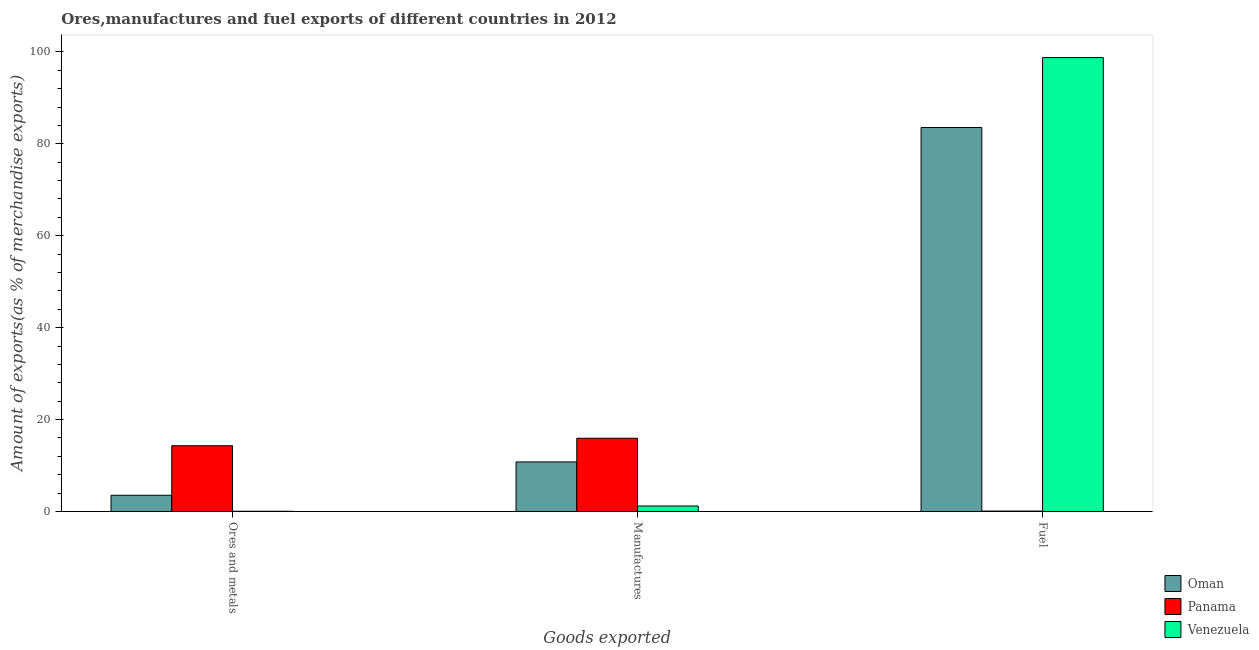Are the number of bars per tick equal to the number of legend labels?
Make the answer very short. Yes. Are the number of bars on each tick of the X-axis equal?
Your response must be concise. Yes. How many bars are there on the 3rd tick from the right?
Ensure brevity in your answer.  3. What is the label of the 3rd group of bars from the left?
Keep it short and to the point. Fuel. What is the percentage of ores and metals exports in Oman?
Your answer should be compact. 3.53. Across all countries, what is the maximum percentage of fuel exports?
Make the answer very short. 98.76. Across all countries, what is the minimum percentage of fuel exports?
Provide a succinct answer. 0.09. In which country was the percentage of ores and metals exports maximum?
Give a very brief answer. Panama. In which country was the percentage of fuel exports minimum?
Offer a very short reply. Panama. What is the total percentage of manufactures exports in the graph?
Provide a short and direct response. 27.91. What is the difference between the percentage of manufactures exports in Oman and that in Panama?
Offer a very short reply. -5.15. What is the difference between the percentage of fuel exports in Oman and the percentage of ores and metals exports in Venezuela?
Keep it short and to the point. 83.5. What is the average percentage of fuel exports per country?
Your answer should be very brief. 60.8. What is the difference between the percentage of fuel exports and percentage of manufactures exports in Oman?
Provide a short and direct response. 72.77. In how many countries, is the percentage of fuel exports greater than 40 %?
Your response must be concise. 2. What is the ratio of the percentage of manufactures exports in Oman to that in Panama?
Make the answer very short. 0.68. Is the percentage of ores and metals exports in Venezuela less than that in Oman?
Ensure brevity in your answer.  Yes. Is the difference between the percentage of manufactures exports in Oman and Panama greater than the difference between the percentage of fuel exports in Oman and Panama?
Keep it short and to the point. No. What is the difference between the highest and the second highest percentage of fuel exports?
Keep it short and to the point. 15.21. What is the difference between the highest and the lowest percentage of fuel exports?
Keep it short and to the point. 98.67. Is the sum of the percentage of ores and metals exports in Oman and Panama greater than the maximum percentage of fuel exports across all countries?
Provide a succinct answer. No. What does the 2nd bar from the left in Manufactures represents?
Your answer should be very brief. Panama. What does the 2nd bar from the right in Ores and metals represents?
Provide a succinct answer. Panama. What is the difference between two consecutive major ticks on the Y-axis?
Offer a very short reply. 20. Are the values on the major ticks of Y-axis written in scientific E-notation?
Provide a short and direct response. No. Does the graph contain any zero values?
Your answer should be compact. No. What is the title of the graph?
Offer a very short reply. Ores,manufactures and fuel exports of different countries in 2012. What is the label or title of the X-axis?
Your answer should be very brief. Goods exported. What is the label or title of the Y-axis?
Ensure brevity in your answer.  Amount of exports(as % of merchandise exports). What is the Amount of exports(as % of merchandise exports) in Oman in Ores and metals?
Your answer should be very brief. 3.53. What is the Amount of exports(as % of merchandise exports) in Panama in Ores and metals?
Offer a terse response. 14.3. What is the Amount of exports(as % of merchandise exports) of Venezuela in Ores and metals?
Offer a terse response. 0.05. What is the Amount of exports(as % of merchandise exports) in Oman in Manufactures?
Your response must be concise. 10.78. What is the Amount of exports(as % of merchandise exports) in Panama in Manufactures?
Give a very brief answer. 15.93. What is the Amount of exports(as % of merchandise exports) in Venezuela in Manufactures?
Provide a short and direct response. 1.19. What is the Amount of exports(as % of merchandise exports) of Oman in Fuel?
Provide a short and direct response. 83.55. What is the Amount of exports(as % of merchandise exports) of Panama in Fuel?
Give a very brief answer. 0.09. What is the Amount of exports(as % of merchandise exports) in Venezuela in Fuel?
Your response must be concise. 98.76. Across all Goods exported, what is the maximum Amount of exports(as % of merchandise exports) of Oman?
Offer a very short reply. 83.55. Across all Goods exported, what is the maximum Amount of exports(as % of merchandise exports) in Panama?
Your answer should be compact. 15.93. Across all Goods exported, what is the maximum Amount of exports(as % of merchandise exports) of Venezuela?
Your response must be concise. 98.76. Across all Goods exported, what is the minimum Amount of exports(as % of merchandise exports) of Oman?
Keep it short and to the point. 3.53. Across all Goods exported, what is the minimum Amount of exports(as % of merchandise exports) in Panama?
Your answer should be very brief. 0.09. Across all Goods exported, what is the minimum Amount of exports(as % of merchandise exports) in Venezuela?
Your answer should be compact. 0.05. What is the total Amount of exports(as % of merchandise exports) of Oman in the graph?
Your response must be concise. 97.86. What is the total Amount of exports(as % of merchandise exports) of Panama in the graph?
Give a very brief answer. 30.33. What is the difference between the Amount of exports(as % of merchandise exports) of Oman in Ores and metals and that in Manufactures?
Give a very brief answer. -7.25. What is the difference between the Amount of exports(as % of merchandise exports) in Panama in Ores and metals and that in Manufactures?
Make the answer very short. -1.63. What is the difference between the Amount of exports(as % of merchandise exports) in Venezuela in Ores and metals and that in Manufactures?
Offer a terse response. -1.14. What is the difference between the Amount of exports(as % of merchandise exports) in Oman in Ores and metals and that in Fuel?
Provide a short and direct response. -80.02. What is the difference between the Amount of exports(as % of merchandise exports) of Panama in Ores and metals and that in Fuel?
Ensure brevity in your answer.  14.22. What is the difference between the Amount of exports(as % of merchandise exports) of Venezuela in Ores and metals and that in Fuel?
Ensure brevity in your answer.  -98.72. What is the difference between the Amount of exports(as % of merchandise exports) in Oman in Manufactures and that in Fuel?
Make the answer very short. -72.77. What is the difference between the Amount of exports(as % of merchandise exports) in Panama in Manufactures and that in Fuel?
Your answer should be compact. 15.85. What is the difference between the Amount of exports(as % of merchandise exports) of Venezuela in Manufactures and that in Fuel?
Ensure brevity in your answer.  -97.57. What is the difference between the Amount of exports(as % of merchandise exports) of Oman in Ores and metals and the Amount of exports(as % of merchandise exports) of Panama in Manufactures?
Provide a short and direct response. -12.4. What is the difference between the Amount of exports(as % of merchandise exports) of Oman in Ores and metals and the Amount of exports(as % of merchandise exports) of Venezuela in Manufactures?
Ensure brevity in your answer.  2.34. What is the difference between the Amount of exports(as % of merchandise exports) in Panama in Ores and metals and the Amount of exports(as % of merchandise exports) in Venezuela in Manufactures?
Make the answer very short. 13.11. What is the difference between the Amount of exports(as % of merchandise exports) in Oman in Ores and metals and the Amount of exports(as % of merchandise exports) in Panama in Fuel?
Your answer should be very brief. 3.44. What is the difference between the Amount of exports(as % of merchandise exports) of Oman in Ores and metals and the Amount of exports(as % of merchandise exports) of Venezuela in Fuel?
Provide a short and direct response. -95.23. What is the difference between the Amount of exports(as % of merchandise exports) in Panama in Ores and metals and the Amount of exports(as % of merchandise exports) in Venezuela in Fuel?
Provide a succinct answer. -84.46. What is the difference between the Amount of exports(as % of merchandise exports) in Oman in Manufactures and the Amount of exports(as % of merchandise exports) in Panama in Fuel?
Give a very brief answer. 10.69. What is the difference between the Amount of exports(as % of merchandise exports) in Oman in Manufactures and the Amount of exports(as % of merchandise exports) in Venezuela in Fuel?
Offer a terse response. -87.98. What is the difference between the Amount of exports(as % of merchandise exports) of Panama in Manufactures and the Amount of exports(as % of merchandise exports) of Venezuela in Fuel?
Offer a very short reply. -82.83. What is the average Amount of exports(as % of merchandise exports) of Oman per Goods exported?
Make the answer very short. 32.62. What is the average Amount of exports(as % of merchandise exports) of Panama per Goods exported?
Provide a short and direct response. 10.11. What is the average Amount of exports(as % of merchandise exports) in Venezuela per Goods exported?
Offer a very short reply. 33.33. What is the difference between the Amount of exports(as % of merchandise exports) in Oman and Amount of exports(as % of merchandise exports) in Panama in Ores and metals?
Ensure brevity in your answer.  -10.77. What is the difference between the Amount of exports(as % of merchandise exports) of Oman and Amount of exports(as % of merchandise exports) of Venezuela in Ores and metals?
Give a very brief answer. 3.48. What is the difference between the Amount of exports(as % of merchandise exports) of Panama and Amount of exports(as % of merchandise exports) of Venezuela in Ores and metals?
Make the answer very short. 14.26. What is the difference between the Amount of exports(as % of merchandise exports) in Oman and Amount of exports(as % of merchandise exports) in Panama in Manufactures?
Make the answer very short. -5.15. What is the difference between the Amount of exports(as % of merchandise exports) of Oman and Amount of exports(as % of merchandise exports) of Venezuela in Manufactures?
Ensure brevity in your answer.  9.59. What is the difference between the Amount of exports(as % of merchandise exports) in Panama and Amount of exports(as % of merchandise exports) in Venezuela in Manufactures?
Keep it short and to the point. 14.74. What is the difference between the Amount of exports(as % of merchandise exports) of Oman and Amount of exports(as % of merchandise exports) of Panama in Fuel?
Provide a succinct answer. 83.46. What is the difference between the Amount of exports(as % of merchandise exports) of Oman and Amount of exports(as % of merchandise exports) of Venezuela in Fuel?
Give a very brief answer. -15.21. What is the difference between the Amount of exports(as % of merchandise exports) of Panama and Amount of exports(as % of merchandise exports) of Venezuela in Fuel?
Keep it short and to the point. -98.67. What is the ratio of the Amount of exports(as % of merchandise exports) in Oman in Ores and metals to that in Manufactures?
Give a very brief answer. 0.33. What is the ratio of the Amount of exports(as % of merchandise exports) of Panama in Ores and metals to that in Manufactures?
Make the answer very short. 0.9. What is the ratio of the Amount of exports(as % of merchandise exports) of Venezuela in Ores and metals to that in Manufactures?
Give a very brief answer. 0.04. What is the ratio of the Amount of exports(as % of merchandise exports) in Oman in Ores and metals to that in Fuel?
Give a very brief answer. 0.04. What is the ratio of the Amount of exports(as % of merchandise exports) in Panama in Ores and metals to that in Fuel?
Your response must be concise. 160.96. What is the ratio of the Amount of exports(as % of merchandise exports) of Venezuela in Ores and metals to that in Fuel?
Offer a very short reply. 0. What is the ratio of the Amount of exports(as % of merchandise exports) of Oman in Manufactures to that in Fuel?
Offer a terse response. 0.13. What is the ratio of the Amount of exports(as % of merchandise exports) of Panama in Manufactures to that in Fuel?
Offer a very short reply. 179.3. What is the ratio of the Amount of exports(as % of merchandise exports) of Venezuela in Manufactures to that in Fuel?
Make the answer very short. 0.01. What is the difference between the highest and the second highest Amount of exports(as % of merchandise exports) in Oman?
Your answer should be compact. 72.77. What is the difference between the highest and the second highest Amount of exports(as % of merchandise exports) of Panama?
Offer a terse response. 1.63. What is the difference between the highest and the second highest Amount of exports(as % of merchandise exports) of Venezuela?
Your response must be concise. 97.57. What is the difference between the highest and the lowest Amount of exports(as % of merchandise exports) in Oman?
Provide a short and direct response. 80.02. What is the difference between the highest and the lowest Amount of exports(as % of merchandise exports) of Panama?
Give a very brief answer. 15.85. What is the difference between the highest and the lowest Amount of exports(as % of merchandise exports) of Venezuela?
Provide a short and direct response. 98.72. 